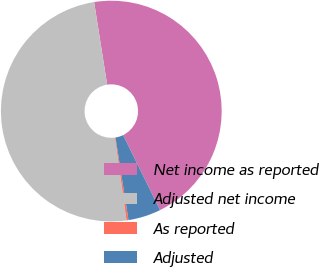Convert chart. <chart><loc_0><loc_0><loc_500><loc_500><pie_chart><fcel>Net income as reported<fcel>Adjusted net income<fcel>As reported<fcel>Adjusted<nl><fcel>45.21%<fcel>49.71%<fcel>0.29%<fcel>4.79%<nl></chart> 